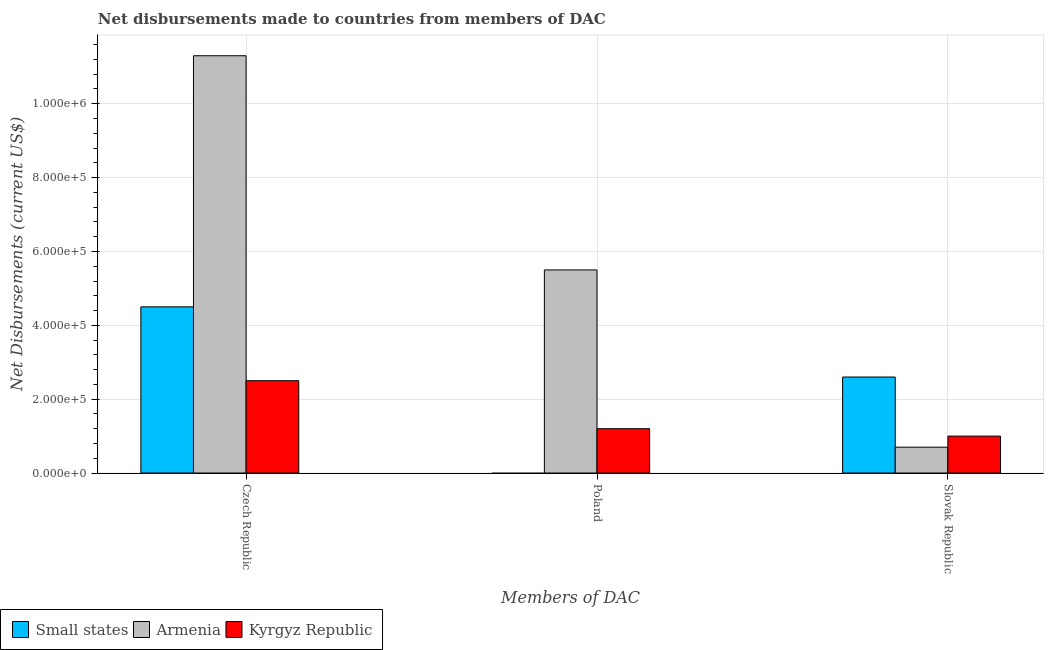How many different coloured bars are there?
Your response must be concise. 3. How many bars are there on the 3rd tick from the right?
Provide a short and direct response. 3. What is the label of the 3rd group of bars from the left?
Provide a succinct answer. Slovak Republic. What is the net disbursements made by poland in Armenia?
Ensure brevity in your answer.  5.50e+05. Across all countries, what is the maximum net disbursements made by poland?
Give a very brief answer. 5.50e+05. Across all countries, what is the minimum net disbursements made by czech republic?
Your answer should be very brief. 2.50e+05. In which country was the net disbursements made by czech republic maximum?
Your answer should be compact. Armenia. What is the total net disbursements made by slovak republic in the graph?
Make the answer very short. 4.30e+05. What is the difference between the net disbursements made by slovak republic in Small states and that in Armenia?
Offer a very short reply. 1.90e+05. What is the difference between the net disbursements made by slovak republic in Armenia and the net disbursements made by czech republic in Small states?
Provide a succinct answer. -3.80e+05. What is the average net disbursements made by czech republic per country?
Offer a terse response. 6.10e+05. What is the difference between the net disbursements made by slovak republic and net disbursements made by czech republic in Armenia?
Your answer should be very brief. -1.06e+06. In how many countries, is the net disbursements made by czech republic greater than 920000 US$?
Your answer should be very brief. 1. What is the ratio of the net disbursements made by poland in Armenia to that in Kyrgyz Republic?
Provide a short and direct response. 4.58. Is the net disbursements made by czech republic in Armenia less than that in Small states?
Your answer should be compact. No. Is the difference between the net disbursements made by poland in Armenia and Kyrgyz Republic greater than the difference between the net disbursements made by czech republic in Armenia and Kyrgyz Republic?
Make the answer very short. No. What is the difference between the highest and the second highest net disbursements made by czech republic?
Keep it short and to the point. 6.80e+05. What is the difference between the highest and the lowest net disbursements made by slovak republic?
Provide a succinct answer. 1.90e+05. Is the sum of the net disbursements made by czech republic in Small states and Kyrgyz Republic greater than the maximum net disbursements made by slovak republic across all countries?
Your answer should be very brief. Yes. Is it the case that in every country, the sum of the net disbursements made by czech republic and net disbursements made by poland is greater than the net disbursements made by slovak republic?
Offer a very short reply. Yes. How many bars are there?
Ensure brevity in your answer.  8. Are all the bars in the graph horizontal?
Give a very brief answer. No. Where does the legend appear in the graph?
Make the answer very short. Bottom left. How many legend labels are there?
Keep it short and to the point. 3. What is the title of the graph?
Make the answer very short. Net disbursements made to countries from members of DAC. Does "Chile" appear as one of the legend labels in the graph?
Ensure brevity in your answer.  No. What is the label or title of the X-axis?
Provide a short and direct response. Members of DAC. What is the label or title of the Y-axis?
Ensure brevity in your answer.  Net Disbursements (current US$). What is the Net Disbursements (current US$) of Armenia in Czech Republic?
Ensure brevity in your answer.  1.13e+06. What is the Net Disbursements (current US$) in Small states in Poland?
Keep it short and to the point. 0. What is the Net Disbursements (current US$) of Armenia in Poland?
Give a very brief answer. 5.50e+05. What is the Net Disbursements (current US$) in Kyrgyz Republic in Poland?
Your response must be concise. 1.20e+05. Across all Members of DAC, what is the maximum Net Disbursements (current US$) of Armenia?
Provide a short and direct response. 1.13e+06. Across all Members of DAC, what is the minimum Net Disbursements (current US$) in Small states?
Your response must be concise. 0. What is the total Net Disbursements (current US$) in Small states in the graph?
Provide a succinct answer. 7.10e+05. What is the total Net Disbursements (current US$) in Armenia in the graph?
Provide a succinct answer. 1.75e+06. What is the difference between the Net Disbursements (current US$) in Armenia in Czech Republic and that in Poland?
Offer a very short reply. 5.80e+05. What is the difference between the Net Disbursements (current US$) of Kyrgyz Republic in Czech Republic and that in Poland?
Give a very brief answer. 1.30e+05. What is the difference between the Net Disbursements (current US$) in Small states in Czech Republic and that in Slovak Republic?
Give a very brief answer. 1.90e+05. What is the difference between the Net Disbursements (current US$) of Armenia in Czech Republic and that in Slovak Republic?
Your answer should be compact. 1.06e+06. What is the difference between the Net Disbursements (current US$) in Armenia in Poland and that in Slovak Republic?
Your answer should be compact. 4.80e+05. What is the difference between the Net Disbursements (current US$) of Small states in Czech Republic and the Net Disbursements (current US$) of Armenia in Poland?
Offer a terse response. -1.00e+05. What is the difference between the Net Disbursements (current US$) in Small states in Czech Republic and the Net Disbursements (current US$) in Kyrgyz Republic in Poland?
Ensure brevity in your answer.  3.30e+05. What is the difference between the Net Disbursements (current US$) in Armenia in Czech Republic and the Net Disbursements (current US$) in Kyrgyz Republic in Poland?
Make the answer very short. 1.01e+06. What is the difference between the Net Disbursements (current US$) of Armenia in Czech Republic and the Net Disbursements (current US$) of Kyrgyz Republic in Slovak Republic?
Provide a short and direct response. 1.03e+06. What is the average Net Disbursements (current US$) in Small states per Members of DAC?
Your response must be concise. 2.37e+05. What is the average Net Disbursements (current US$) in Armenia per Members of DAC?
Offer a very short reply. 5.83e+05. What is the average Net Disbursements (current US$) of Kyrgyz Republic per Members of DAC?
Provide a succinct answer. 1.57e+05. What is the difference between the Net Disbursements (current US$) of Small states and Net Disbursements (current US$) of Armenia in Czech Republic?
Provide a short and direct response. -6.80e+05. What is the difference between the Net Disbursements (current US$) in Small states and Net Disbursements (current US$) in Kyrgyz Republic in Czech Republic?
Give a very brief answer. 2.00e+05. What is the difference between the Net Disbursements (current US$) in Armenia and Net Disbursements (current US$) in Kyrgyz Republic in Czech Republic?
Your answer should be compact. 8.80e+05. What is the difference between the Net Disbursements (current US$) of Small states and Net Disbursements (current US$) of Armenia in Slovak Republic?
Your response must be concise. 1.90e+05. What is the ratio of the Net Disbursements (current US$) in Armenia in Czech Republic to that in Poland?
Offer a terse response. 2.05. What is the ratio of the Net Disbursements (current US$) of Kyrgyz Republic in Czech Republic to that in Poland?
Ensure brevity in your answer.  2.08. What is the ratio of the Net Disbursements (current US$) in Small states in Czech Republic to that in Slovak Republic?
Offer a very short reply. 1.73. What is the ratio of the Net Disbursements (current US$) in Armenia in Czech Republic to that in Slovak Republic?
Offer a very short reply. 16.14. What is the ratio of the Net Disbursements (current US$) of Kyrgyz Republic in Czech Republic to that in Slovak Republic?
Provide a succinct answer. 2.5. What is the ratio of the Net Disbursements (current US$) of Armenia in Poland to that in Slovak Republic?
Offer a very short reply. 7.86. What is the ratio of the Net Disbursements (current US$) in Kyrgyz Republic in Poland to that in Slovak Republic?
Your response must be concise. 1.2. What is the difference between the highest and the second highest Net Disbursements (current US$) in Armenia?
Provide a succinct answer. 5.80e+05. What is the difference between the highest and the lowest Net Disbursements (current US$) of Armenia?
Ensure brevity in your answer.  1.06e+06. 